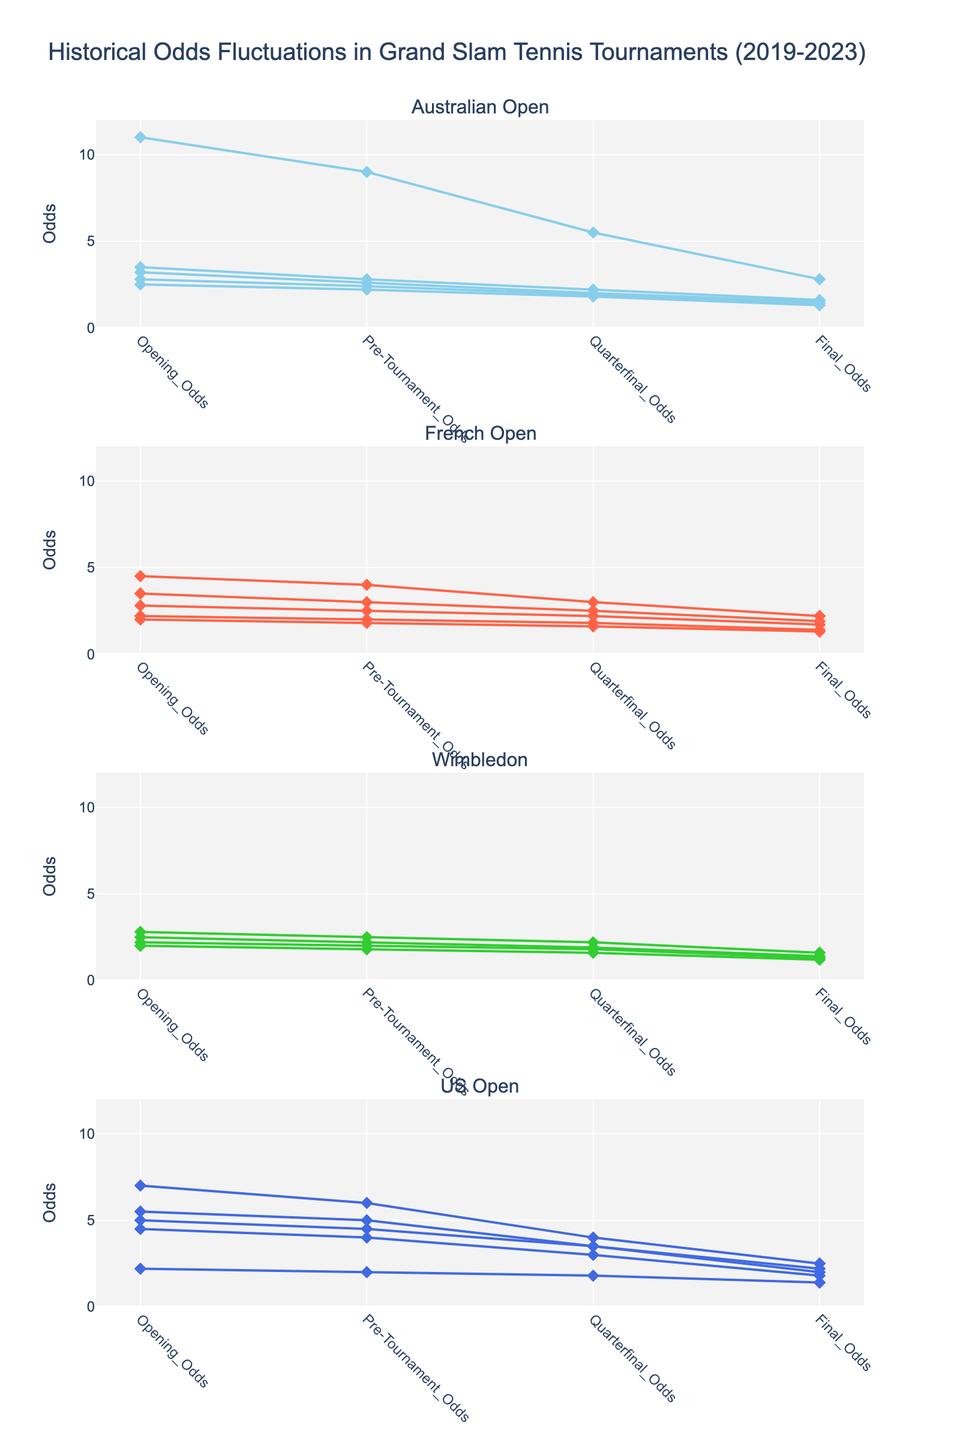What is the overall title of the figure? The title is located at the top of the figure and summarizes the entire visualized data.
Answer: Historical Odds Fluctuations in Grand Slam Tennis Tournaments (2019-2023) Which tournament has the color blue? Each tournament has a unique color representation; blue represents the US Open.
Answer: US Open What is the range of the y-axis for each subplot? The y-axis range is specified within each subplot, starting from 0 and ending at 12.
Answer: 0 to 12 What was the final odds for Novak Djokovic in the 2023 Australian Open? To find this, look at the subplot titled 'Australian Open', and locate the line representing Novak Djokovic in 2023. The final point on this line shows his final odds, which is 1.3.
Answer: 1.3 Who had the highest opening odds among the French Open winners from 2019-2023? Examine the French Open subplot and compare the opening odds for each player. Rafael Nadal had the highest opening odds in 2022 with a value of 4.5.
Answer: Rafael Nadal (4.5 in 2022) Compare the final odds for Novak Djokovic in Wimbledon 2021 and 2023. Which year had lower final odds? Refer to the 'Wimbledon' subplot, look up the lines for Novak Djokovic in 2021 and 2023, and compare the final odds values. For 2023, the final odds were 1.2, while for 2021, it was 1.4. Thus, 2023 had lower final odds.
Answer: 2023 (1.2) How did Rafael Nadal's quarterfinal odds in the 2019 French Open differ from his final odds in the 2023 French Open? Identify Rafael Nadal's quarterfinal odds in the 2019 French Open and his final odds in the 2023 French Open. The quarterfinal odds in 2019 were 1.8, and the final odds in 2023 were 2.2. The difference is 2.2 - 1.8 = 0.4.
Answer: 0.4 Which tournament saw the largest drop from opening odds to final odds for any year and player? Analyze each subplot to find the player and year combination that had the largest decrease from opening odds to final odds. Rafael Nadal in the 2022 Australian Open had a drop from 11.0 to 2.8, a difference of 8.2, which is the largest.
Answer: Australian Open 2022 (Rafael Nadal, drop of 8.2) What trends are observable in Novak Djokovic's odds in the Australian Open over the years 2019 to 2023? By inspecting the subplot labeled 'Australian Open', look at Novak Djokovic's lines and observe that his opening odds have consecutively decreased each year: 3.5 (2019), 3.2 (2020), 2.8 (2021), 2.5 (2023), and his final odds followed a similar downward trend.
Answer: Decreasing trend in both opening and final odds What was the overall lowest final odds recorded and in which tournament and year? Scan through all subplots to find the minimum final odds. The lowest final odds are 1.2, recorded by Novak Djokovic in the 2023 Wimbledon.
Answer: Novak Djokovic, Wimbledon 2023 (1.2) 